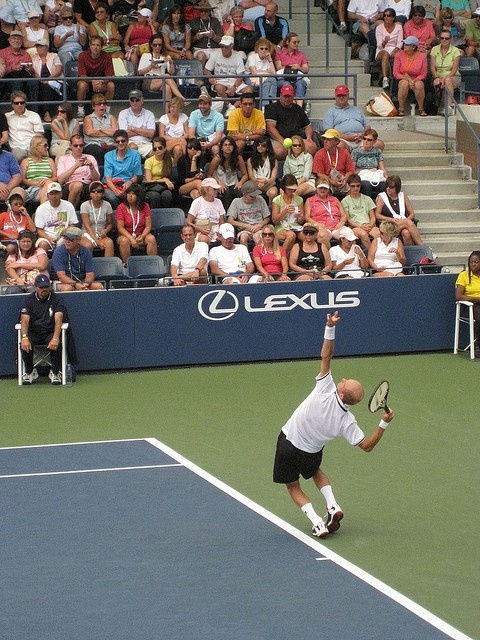Describe the objects in this image and their specific colors. I can see people in darkgray, black, brown, and gray tones, people in darkgray, lightgray, black, and olive tones, people in darkgray, black, and gray tones, people in darkgray, brown, pink, lightpink, and black tones, and people in darkgray, black, navy, gray, and brown tones in this image. 